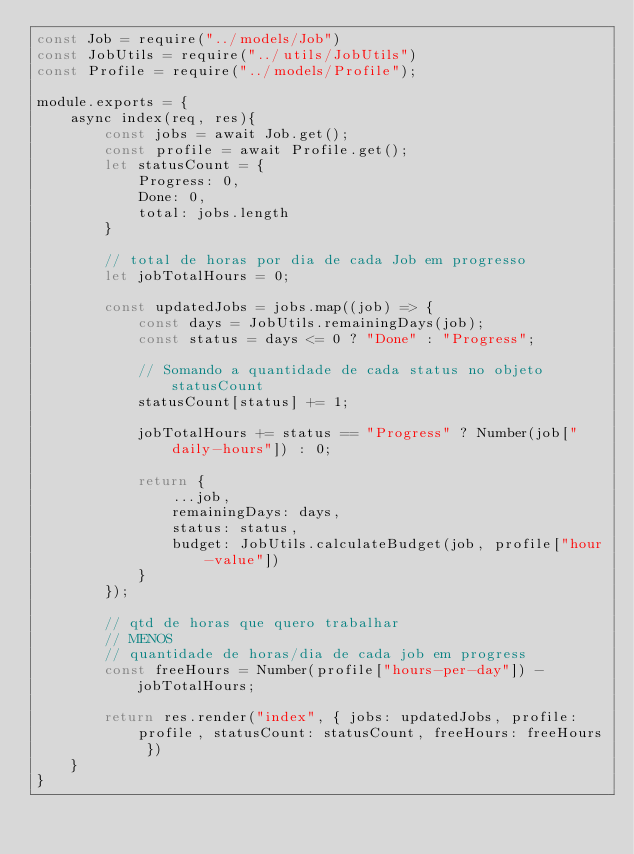Convert code to text. <code><loc_0><loc_0><loc_500><loc_500><_JavaScript_>const Job = require("../models/Job")
const JobUtils = require("../utils/JobUtils")
const Profile = require("../models/Profile");

module.exports = {
    async index(req, res){
        const jobs = await Job.get();
        const profile = await Profile.get();
        let statusCount = {
            Progress: 0,
            Done: 0,
            total: jobs.length
        }

        // total de horas por dia de cada Job em progresso
        let jobTotalHours = 0;

        const updatedJobs = jobs.map((job) => {
            const days = JobUtils.remainingDays(job);
            const status = days <= 0 ? "Done" : "Progress";
    
            // Somando a quantidade de cada status no objeto statusCount
            statusCount[status] += 1;

            jobTotalHours += status == "Progress" ? Number(job["daily-hours"]) : 0;

            return {
                ...job,
                remainingDays: days,
                status: status,
                budget: JobUtils.calculateBudget(job, profile["hour-value"])
            }
        });
        
        // qtd de horas que quero trabalhar
        // MENOS 
        // quantidade de horas/dia de cada job em progress
        const freeHours = Number(profile["hours-per-day"]) - jobTotalHours;

        return res.render("index", { jobs: updatedJobs, profile: profile, statusCount: statusCount, freeHours: freeHours })
    }
}
</code> 